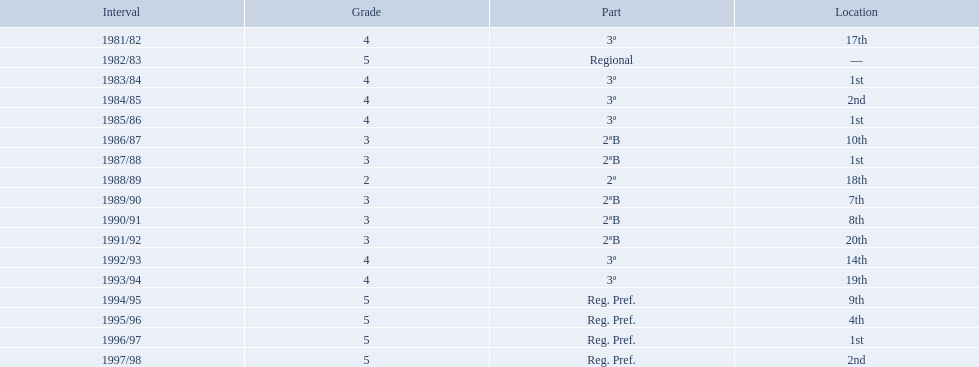Which years did the team have a season? 1981/82, 1982/83, 1983/84, 1984/85, 1985/86, 1986/87, 1987/88, 1988/89, 1989/90, 1990/91, 1991/92, 1992/93, 1993/94, 1994/95, 1995/96, 1996/97, 1997/98. Which of those years did the team place outside the top 10? 1981/82, 1988/89, 1991/92, 1992/93, 1993/94. Which of the years in which the team placed outside the top 10 did they have their worst performance? 1991/92. 